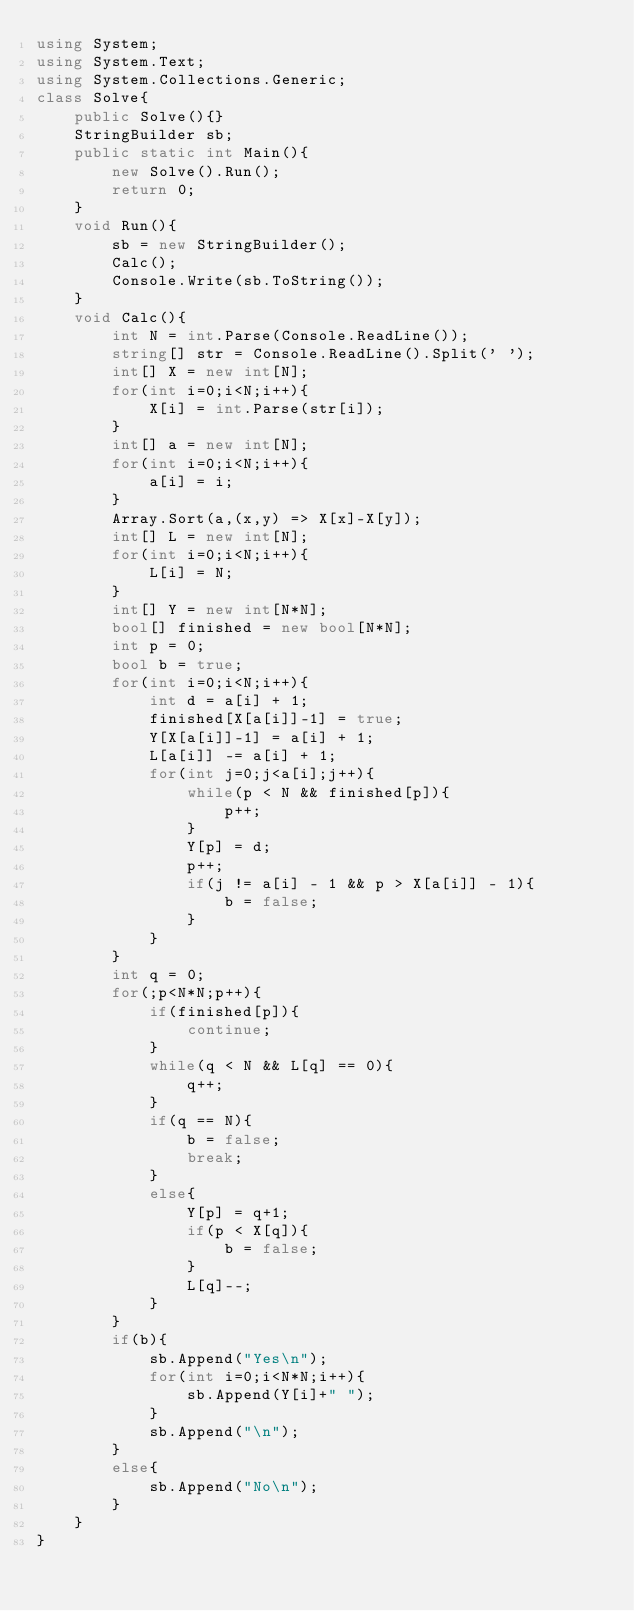Convert code to text. <code><loc_0><loc_0><loc_500><loc_500><_C#_>using System;
using System.Text;
using System.Collections.Generic;
class Solve{
    public Solve(){}
    StringBuilder sb;
    public static int Main(){
        new Solve().Run();
        return 0;
    }
    void Run(){
        sb = new StringBuilder();
        Calc();
        Console.Write(sb.ToString());
    }
    void Calc(){
        int N = int.Parse(Console.ReadLine());
        string[] str = Console.ReadLine().Split(' ');
        int[] X = new int[N];
        for(int i=0;i<N;i++){
            X[i] = int.Parse(str[i]);
        }
        int[] a = new int[N];
        for(int i=0;i<N;i++){
            a[i] = i;
        }
        Array.Sort(a,(x,y) => X[x]-X[y]);
        int[] L = new int[N];
        for(int i=0;i<N;i++){
            L[i] = N;
        }
        int[] Y = new int[N*N];
        bool[] finished = new bool[N*N];
        int p = 0;
        bool b = true;
        for(int i=0;i<N;i++){
            int d = a[i] + 1;
            finished[X[a[i]]-1] = true;
            Y[X[a[i]]-1] = a[i] + 1;
            L[a[i]] -= a[i] + 1; 
            for(int j=0;j<a[i];j++){
                while(p < N && finished[p]){
                    p++;
                }
                Y[p] = d;
                p++;
                if(j != a[i] - 1 && p > X[a[i]] - 1){
                    b = false;
                }
            }
        }
        int q = 0;
        for(;p<N*N;p++){
            if(finished[p]){
                continue;
            }
            while(q < N && L[q] == 0){
                q++;
            }
            if(q == N){
                b = false;
                break;
            }
            else{
                Y[p] = q+1;
                if(p < X[q]){
                    b = false;
                }
                L[q]--;
            }
        }
        if(b){
            sb.Append("Yes\n");
            for(int i=0;i<N*N;i++){
                sb.Append(Y[i]+" ");
            }
            sb.Append("\n");
        }
        else{
            sb.Append("No\n");
        }
    }
}</code> 